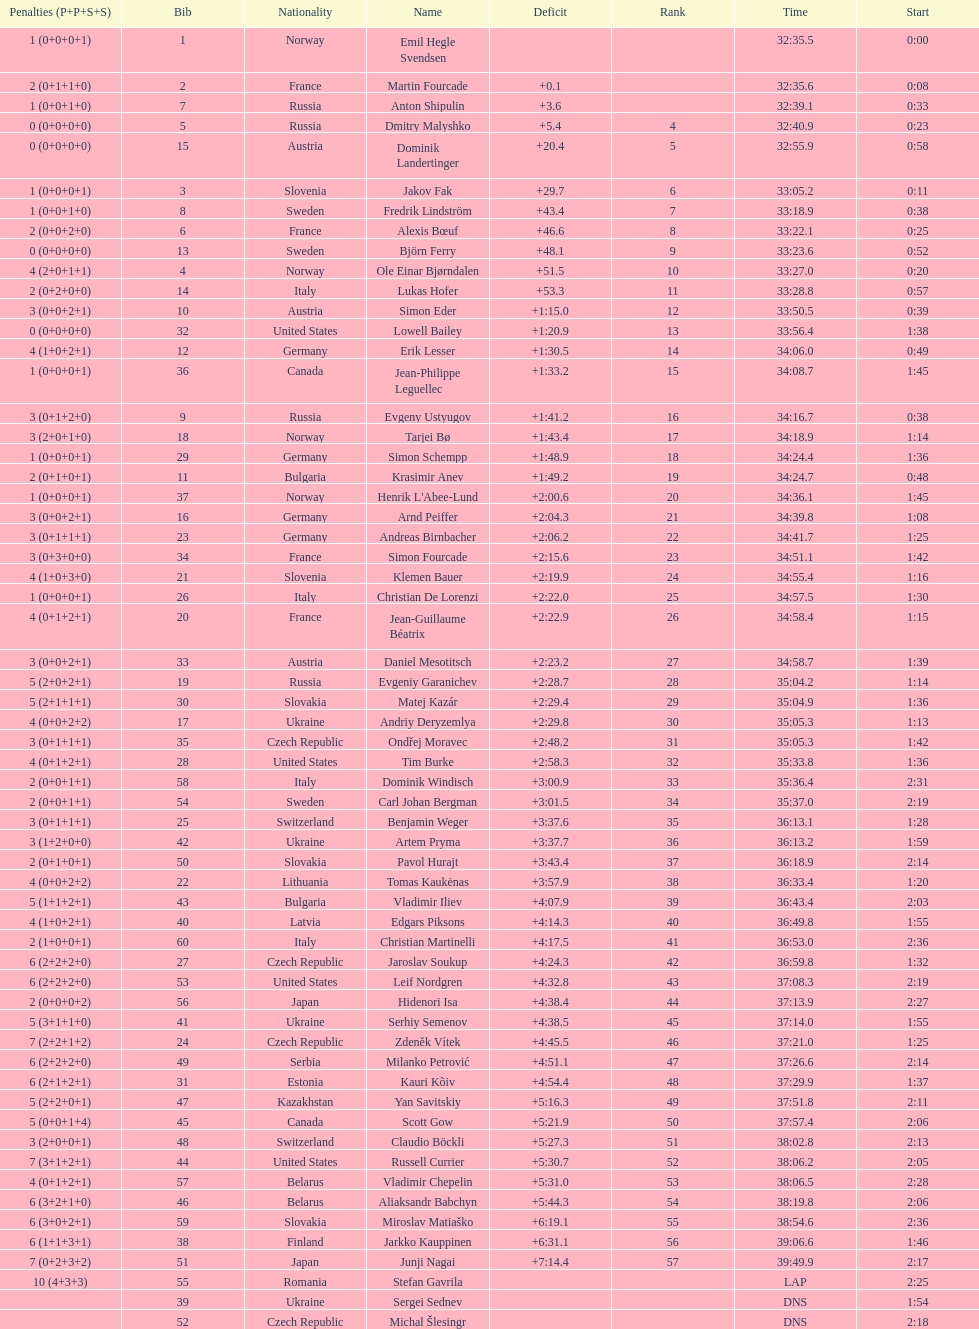Who is the top ranked runner of sweden? Fredrik Lindström. Help me parse the entirety of this table. {'header': ['Penalties (P+P+S+S)', 'Bib', 'Nationality', 'Name', 'Deficit', 'Rank', 'Time', 'Start'], 'rows': [['1 (0+0+0+1)', '1', 'Norway', 'Emil Hegle Svendsen', '', '', '32:35.5', '0:00'], ['2 (0+1+1+0)', '2', 'France', 'Martin Fourcade', '+0.1', '', '32:35.6', '0:08'], ['1 (0+0+1+0)', '7', 'Russia', 'Anton Shipulin', '+3.6', '', '32:39.1', '0:33'], ['0 (0+0+0+0)', '5', 'Russia', 'Dmitry Malyshko', '+5.4', '4', '32:40.9', '0:23'], ['0 (0+0+0+0)', '15', 'Austria', 'Dominik Landertinger', '+20.4', '5', '32:55.9', '0:58'], ['1 (0+0+0+1)', '3', 'Slovenia', 'Jakov Fak', '+29.7', '6', '33:05.2', '0:11'], ['1 (0+0+1+0)', '8', 'Sweden', 'Fredrik Lindström', '+43.4', '7', '33:18.9', '0:38'], ['2 (0+0+2+0)', '6', 'France', 'Alexis Bœuf', '+46.6', '8', '33:22.1', '0:25'], ['0 (0+0+0+0)', '13', 'Sweden', 'Björn Ferry', '+48.1', '9', '33:23.6', '0:52'], ['4 (2+0+1+1)', '4', 'Norway', 'Ole Einar Bjørndalen', '+51.5', '10', '33:27.0', '0:20'], ['2 (0+2+0+0)', '14', 'Italy', 'Lukas Hofer', '+53.3', '11', '33:28.8', '0:57'], ['3 (0+0+2+1)', '10', 'Austria', 'Simon Eder', '+1:15.0', '12', '33:50.5', '0:39'], ['0 (0+0+0+0)', '32', 'United States', 'Lowell Bailey', '+1:20.9', '13', '33:56.4', '1:38'], ['4 (1+0+2+1)', '12', 'Germany', 'Erik Lesser', '+1:30.5', '14', '34:06.0', '0:49'], ['1 (0+0+0+1)', '36', 'Canada', 'Jean-Philippe Leguellec', '+1:33.2', '15', '34:08.7', '1:45'], ['3 (0+1+2+0)', '9', 'Russia', 'Evgeny Ustyugov', '+1:41.2', '16', '34:16.7', '0:38'], ['3 (2+0+1+0)', '18', 'Norway', 'Tarjei Bø', '+1:43.4', '17', '34:18.9', '1:14'], ['1 (0+0+0+1)', '29', 'Germany', 'Simon Schempp', '+1:48.9', '18', '34:24.4', '1:36'], ['2 (0+1+0+1)', '11', 'Bulgaria', 'Krasimir Anev', '+1:49.2', '19', '34:24.7', '0:48'], ['1 (0+0+0+1)', '37', 'Norway', "Henrik L'Abee-Lund", '+2:00.6', '20', '34:36.1', '1:45'], ['3 (0+0+2+1)', '16', 'Germany', 'Arnd Peiffer', '+2:04.3', '21', '34:39.8', '1:08'], ['3 (0+1+1+1)', '23', 'Germany', 'Andreas Birnbacher', '+2:06.2', '22', '34:41.7', '1:25'], ['3 (0+3+0+0)', '34', 'France', 'Simon Fourcade', '+2:15.6', '23', '34:51.1', '1:42'], ['4 (1+0+3+0)', '21', 'Slovenia', 'Klemen Bauer', '+2:19.9', '24', '34:55.4', '1:16'], ['1 (0+0+0+1)', '26', 'Italy', 'Christian De Lorenzi', '+2:22.0', '25', '34:57.5', '1:30'], ['4 (0+1+2+1)', '20', 'France', 'Jean-Guillaume Béatrix', '+2:22.9', '26', '34:58.4', '1:15'], ['3 (0+0+2+1)', '33', 'Austria', 'Daniel Mesotitsch', '+2:23.2', '27', '34:58.7', '1:39'], ['5 (2+0+2+1)', '19', 'Russia', 'Evgeniy Garanichev', '+2:28.7', '28', '35:04.2', '1:14'], ['5 (2+1+1+1)', '30', 'Slovakia', 'Matej Kazár', '+2:29.4', '29', '35:04.9', '1:36'], ['4 (0+0+2+2)', '17', 'Ukraine', 'Andriy Deryzemlya', '+2:29.8', '30', '35:05.3', '1:13'], ['3 (0+1+1+1)', '35', 'Czech Republic', 'Ondřej Moravec', '+2:48.2', '31', '35:05.3', '1:42'], ['4 (0+1+2+1)', '28', 'United States', 'Tim Burke', '+2:58.3', '32', '35:33.8', '1:36'], ['2 (0+0+1+1)', '58', 'Italy', 'Dominik Windisch', '+3:00.9', '33', '35:36.4', '2:31'], ['2 (0+0+1+1)', '54', 'Sweden', 'Carl Johan Bergman', '+3:01.5', '34', '35:37.0', '2:19'], ['3 (0+1+1+1)', '25', 'Switzerland', 'Benjamin Weger', '+3:37.6', '35', '36:13.1', '1:28'], ['3 (1+2+0+0)', '42', 'Ukraine', 'Artem Pryma', '+3:37.7', '36', '36:13.2', '1:59'], ['2 (0+1+0+1)', '50', 'Slovakia', 'Pavol Hurajt', '+3:43.4', '37', '36:18.9', '2:14'], ['4 (0+0+2+2)', '22', 'Lithuania', 'Tomas Kaukėnas', '+3:57.9', '38', '36:33.4', '1:20'], ['5 (1+1+2+1)', '43', 'Bulgaria', 'Vladimir Iliev', '+4:07.9', '39', '36:43.4', '2:03'], ['4 (1+0+2+1)', '40', 'Latvia', 'Edgars Piksons', '+4:14.3', '40', '36:49.8', '1:55'], ['2 (1+0+0+1)', '60', 'Italy', 'Christian Martinelli', '+4:17.5', '41', '36:53.0', '2:36'], ['6 (2+2+2+0)', '27', 'Czech Republic', 'Jaroslav Soukup', '+4:24.3', '42', '36:59.8', '1:32'], ['6 (2+2+2+0)', '53', 'United States', 'Leif Nordgren', '+4:32.8', '43', '37:08.3', '2:19'], ['2 (0+0+0+2)', '56', 'Japan', 'Hidenori Isa', '+4:38.4', '44', '37:13.9', '2:27'], ['5 (3+1+1+0)', '41', 'Ukraine', 'Serhiy Semenov', '+4:38.5', '45', '37:14.0', '1:55'], ['7 (2+2+1+2)', '24', 'Czech Republic', 'Zdeněk Vítek', '+4:45.5', '46', '37:21.0', '1:25'], ['6 (2+2+2+0)', '49', 'Serbia', 'Milanko Petrović', '+4:51.1', '47', '37:26.6', '2:14'], ['6 (2+1+2+1)', '31', 'Estonia', 'Kauri Kõiv', '+4:54.4', '48', '37:29.9', '1:37'], ['5 (2+2+0+1)', '47', 'Kazakhstan', 'Yan Savitskiy', '+5:16.3', '49', '37:51.8', '2:11'], ['5 (0+0+1+4)', '45', 'Canada', 'Scott Gow', '+5:21.9', '50', '37:57.4', '2:06'], ['3 (2+0+0+1)', '48', 'Switzerland', 'Claudio Böckli', '+5:27.3', '51', '38:02.8', '2:13'], ['7 (3+1+2+1)', '44', 'United States', 'Russell Currier', '+5:30.7', '52', '38:06.2', '2:05'], ['4 (0+1+2+1)', '57', 'Belarus', 'Vladimir Chepelin', '+5:31.0', '53', '38:06.5', '2:28'], ['6 (3+2+1+0)', '46', 'Belarus', 'Aliaksandr Babchyn', '+5:44.3', '54', '38:19.8', '2:06'], ['6 (3+0+2+1)', '59', 'Slovakia', 'Miroslav Matiaško', '+6:19.1', '55', '38:54.6', '2:36'], ['6 (1+1+3+1)', '38', 'Finland', 'Jarkko Kauppinen', '+6:31.1', '56', '39:06.6', '1:46'], ['7 (0+2+3+2)', '51', 'Japan', 'Junji Nagai', '+7:14.4', '57', '39:49.9', '2:17'], ['10 (4+3+3)', '55', 'Romania', 'Stefan Gavrila', '', '', 'LAP', '2:25'], ['', '39', 'Ukraine', 'Sergei Sednev', '', '', 'DNS', '1:54'], ['', '52', 'Czech Republic', 'Michal Šlesingr', '', '', 'DNS', '2:18']]} 